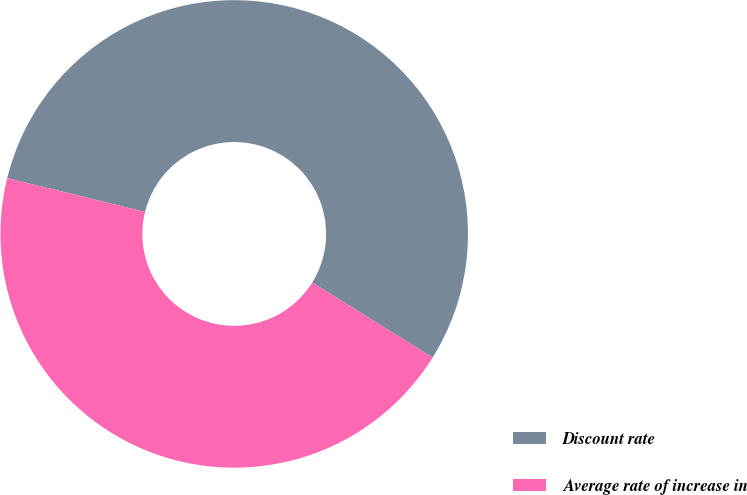Convert chart. <chart><loc_0><loc_0><loc_500><loc_500><pie_chart><fcel>Discount rate<fcel>Average rate of increase in<nl><fcel>55.03%<fcel>44.97%<nl></chart> 